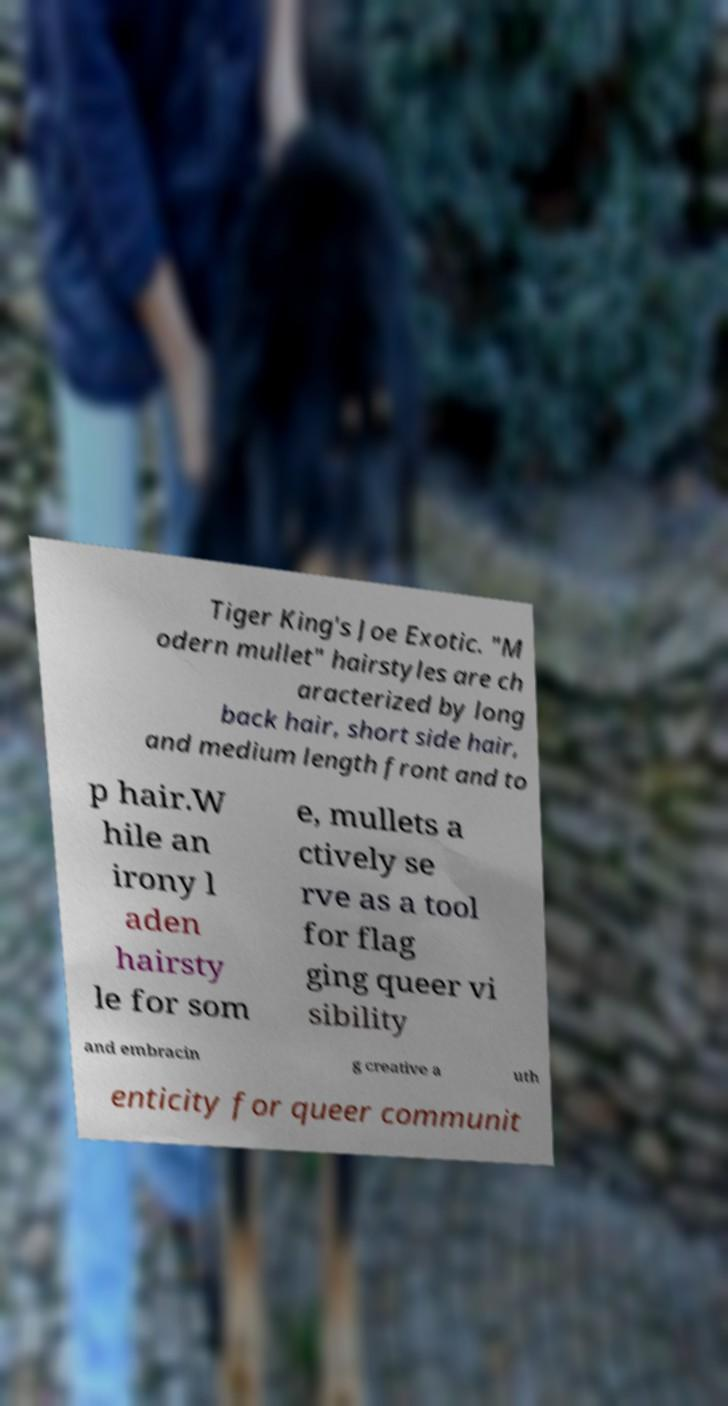Please read and relay the text visible in this image. What does it say? Tiger King's Joe Exotic. "M odern mullet" hairstyles are ch aracterized by long back hair, short side hair, and medium length front and to p hair.W hile an irony l aden hairsty le for som e, mullets a ctively se rve as a tool for flag ging queer vi sibility and embracin g creative a uth enticity for queer communit 